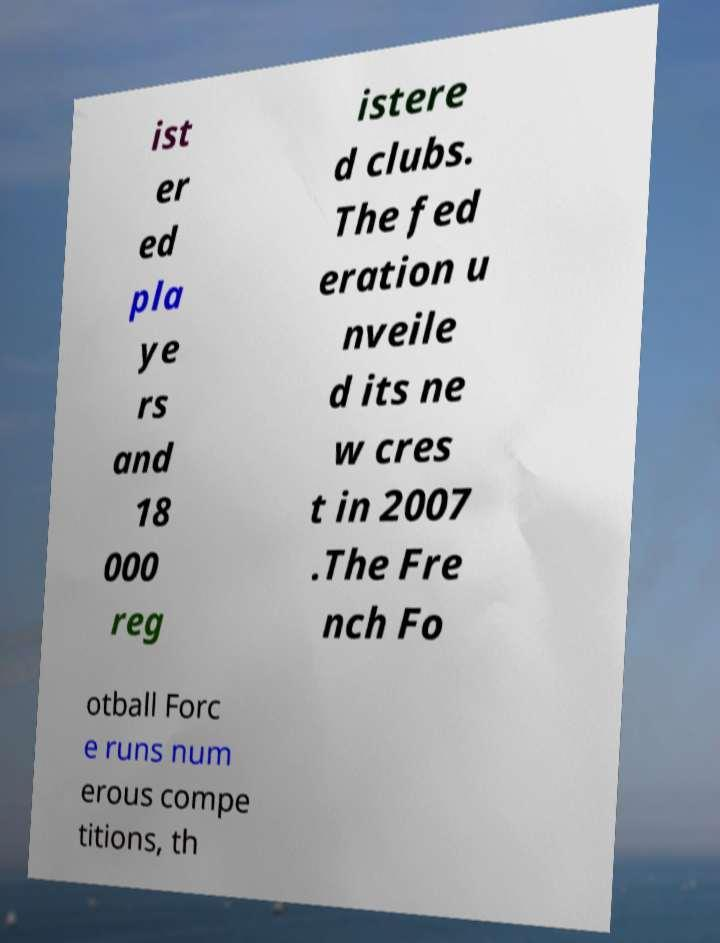Please identify and transcribe the text found in this image. ist er ed pla ye rs and 18 000 reg istere d clubs. The fed eration u nveile d its ne w cres t in 2007 .The Fre nch Fo otball Forc e runs num erous compe titions, th 